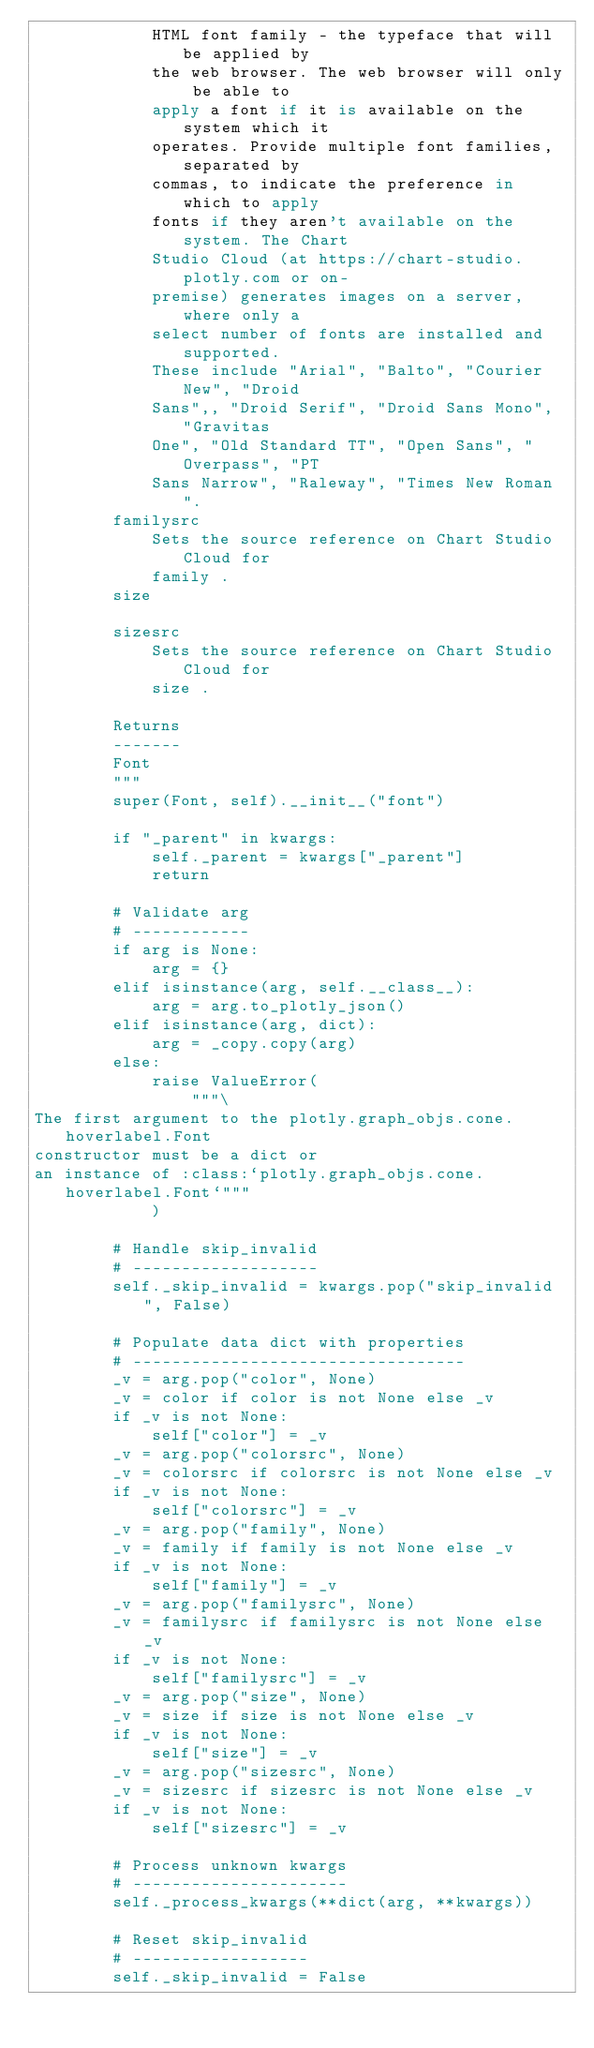<code> <loc_0><loc_0><loc_500><loc_500><_Python_>            HTML font family - the typeface that will be applied by
            the web browser. The web browser will only be able to
            apply a font if it is available on the system which it
            operates. Provide multiple font families, separated by
            commas, to indicate the preference in which to apply
            fonts if they aren't available on the system. The Chart
            Studio Cloud (at https://chart-studio.plotly.com or on-
            premise) generates images on a server, where only a
            select number of fonts are installed and supported.
            These include "Arial", "Balto", "Courier New", "Droid
            Sans",, "Droid Serif", "Droid Sans Mono", "Gravitas
            One", "Old Standard TT", "Open Sans", "Overpass", "PT
            Sans Narrow", "Raleway", "Times New Roman".
        familysrc
            Sets the source reference on Chart Studio Cloud for
            family .
        size

        sizesrc
            Sets the source reference on Chart Studio Cloud for
            size .

        Returns
        -------
        Font
        """
        super(Font, self).__init__("font")

        if "_parent" in kwargs:
            self._parent = kwargs["_parent"]
            return

        # Validate arg
        # ------------
        if arg is None:
            arg = {}
        elif isinstance(arg, self.__class__):
            arg = arg.to_plotly_json()
        elif isinstance(arg, dict):
            arg = _copy.copy(arg)
        else:
            raise ValueError(
                """\
The first argument to the plotly.graph_objs.cone.hoverlabel.Font 
constructor must be a dict or 
an instance of :class:`plotly.graph_objs.cone.hoverlabel.Font`"""
            )

        # Handle skip_invalid
        # -------------------
        self._skip_invalid = kwargs.pop("skip_invalid", False)

        # Populate data dict with properties
        # ----------------------------------
        _v = arg.pop("color", None)
        _v = color if color is not None else _v
        if _v is not None:
            self["color"] = _v
        _v = arg.pop("colorsrc", None)
        _v = colorsrc if colorsrc is not None else _v
        if _v is not None:
            self["colorsrc"] = _v
        _v = arg.pop("family", None)
        _v = family if family is not None else _v
        if _v is not None:
            self["family"] = _v
        _v = arg.pop("familysrc", None)
        _v = familysrc if familysrc is not None else _v
        if _v is not None:
            self["familysrc"] = _v
        _v = arg.pop("size", None)
        _v = size if size is not None else _v
        if _v is not None:
            self["size"] = _v
        _v = arg.pop("sizesrc", None)
        _v = sizesrc if sizesrc is not None else _v
        if _v is not None:
            self["sizesrc"] = _v

        # Process unknown kwargs
        # ----------------------
        self._process_kwargs(**dict(arg, **kwargs))

        # Reset skip_invalid
        # ------------------
        self._skip_invalid = False
</code> 